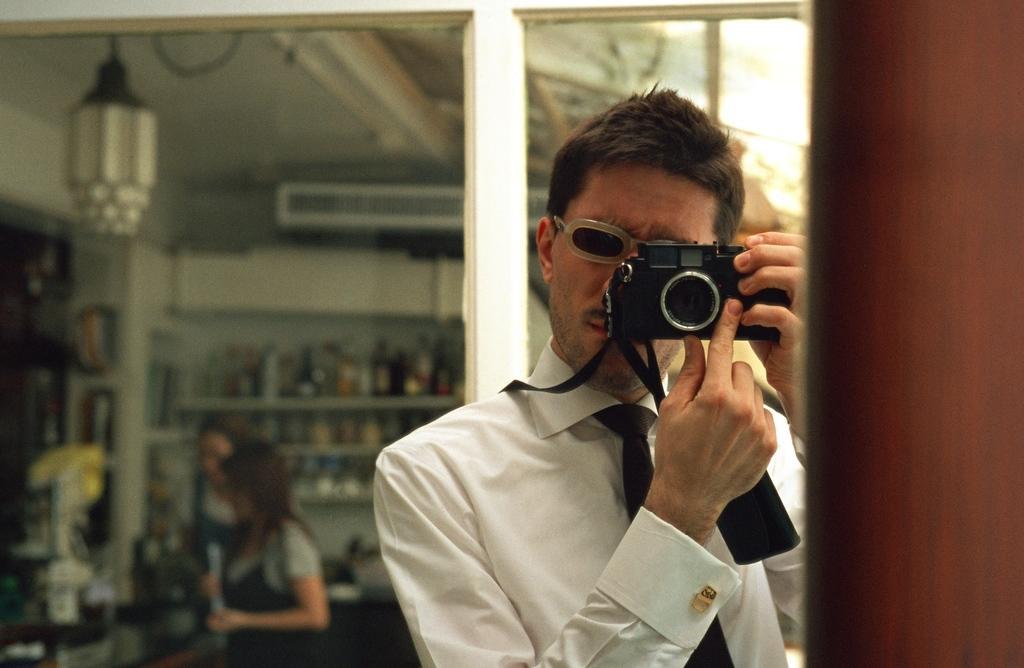Could you give a brief overview of what you see in this image? In this picture e can see a man holding camera in his hand and taking picture and he wore white color shirt, tie, goggles and in background we can see two women standing, racks and items in it, light. 